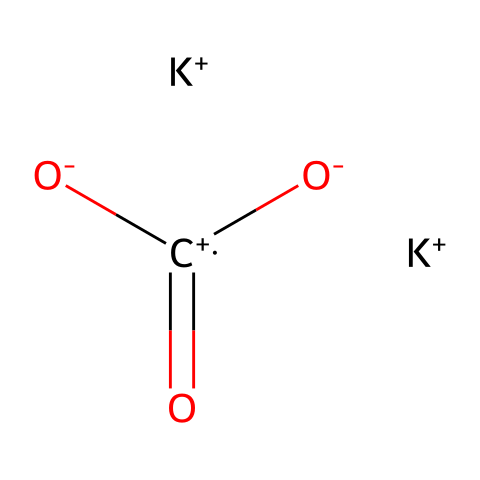What is the molecular formula of this chemical? The SMILES representation indicates the number of each type of atom present. Here, K appears twice (indicating two potassium atoms), C appears once (one carbon atom), and O appears three times (three oxygen atoms), leading to the formula K2CO3.
Answer: K2CO3 How many oxygen atoms are present in this compound? In the SMILES notation, there are three oxygen atoms denoted by the 'O' appearance in the structure, confirming that there are three oxygens.
Answer: 3 What type of chemical compound is potassium carbonate classified as? Given that potassium carbonate can donate hydroxide ions in solution, it is classified as a base. This aligns with the definition of bases in chemistry.
Answer: base What is the oxidation state of carbon in K2CO3? To determine the oxidation state of carbon in this compound, we use the rule that the overall charge must equal zero. Potassium has an oxidation state of +1 and each oxygen is -2. Thus: 2(+1) + x + 3(-2) = 0, leading to x = +4 for carbon.
Answer: +4 What role does potassium carbonate play in glass manufacturing? Potassium carbonate serves as a flux in glass manufacturing, lowering the melting temperature of silica and helping to produce a clearer glass. This function is essential for the glass production process.
Answer: flux How many potassium atoms are present in the chemical structure? The structure shows two potassium ions 'K+' distinctly represented in the SMILES notation. Therefore, there are two potassium atoms.
Answer: 2 What is the primary structural role of carbonate in K2CO3? The carbonate ion (CO3) provides the structure that allows the interlinking of glass networks, contributing to the framework of glass. Its presence is crucial for the overall stability and properties of the resulting glass.
Answer: framework 